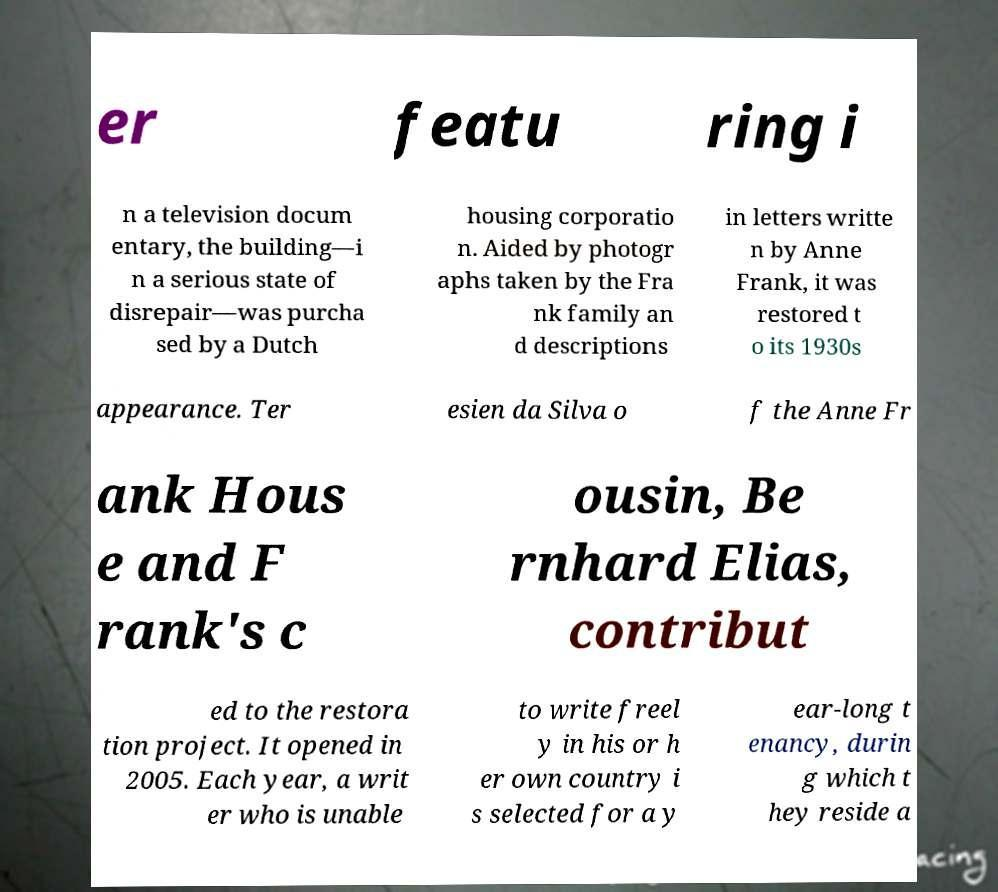What messages or text are displayed in this image? I need them in a readable, typed format. er featu ring i n a television docum entary, the building—i n a serious state of disrepair—was purcha sed by a Dutch housing corporatio n. Aided by photogr aphs taken by the Fra nk family an d descriptions in letters writte n by Anne Frank, it was restored t o its 1930s appearance. Ter esien da Silva o f the Anne Fr ank Hous e and F rank's c ousin, Be rnhard Elias, contribut ed to the restora tion project. It opened in 2005. Each year, a writ er who is unable to write freel y in his or h er own country i s selected for a y ear-long t enancy, durin g which t hey reside a 